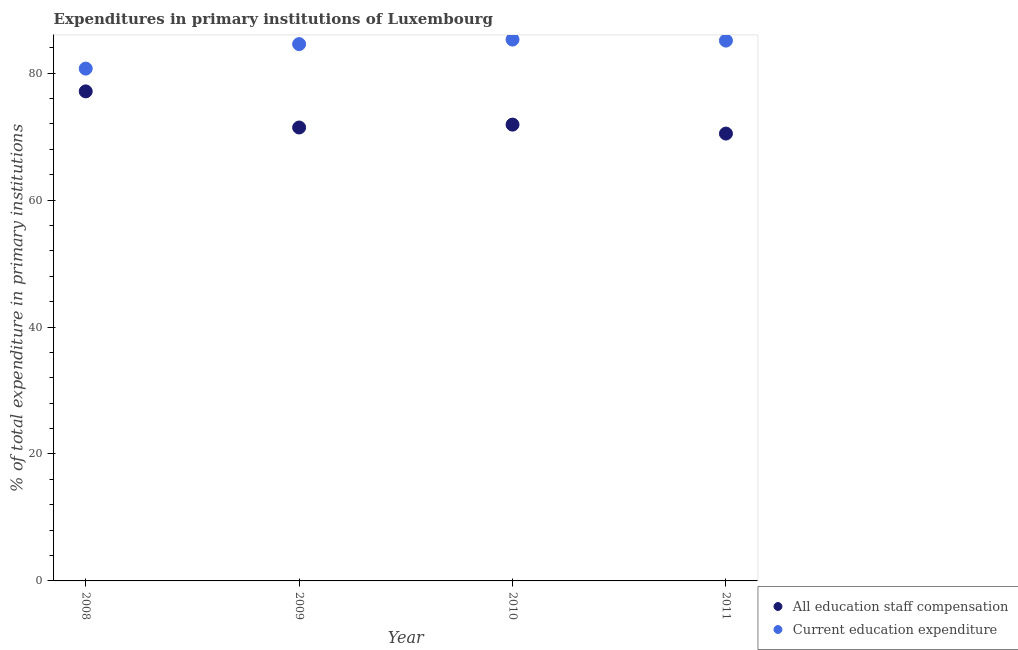What is the expenditure in staff compensation in 2010?
Give a very brief answer. 71.89. Across all years, what is the maximum expenditure in education?
Offer a very short reply. 85.29. Across all years, what is the minimum expenditure in staff compensation?
Your answer should be very brief. 70.48. In which year was the expenditure in education maximum?
Your response must be concise. 2010. What is the total expenditure in staff compensation in the graph?
Provide a succinct answer. 290.94. What is the difference between the expenditure in staff compensation in 2009 and that in 2011?
Keep it short and to the point. 0.96. What is the difference between the expenditure in staff compensation in 2011 and the expenditure in education in 2010?
Offer a terse response. -14.81. What is the average expenditure in staff compensation per year?
Offer a very short reply. 72.73. In the year 2008, what is the difference between the expenditure in staff compensation and expenditure in education?
Keep it short and to the point. -3.59. What is the ratio of the expenditure in staff compensation in 2008 to that in 2011?
Give a very brief answer. 1.09. Is the expenditure in education in 2009 less than that in 2010?
Make the answer very short. Yes. What is the difference between the highest and the second highest expenditure in staff compensation?
Your answer should be very brief. 5.24. What is the difference between the highest and the lowest expenditure in staff compensation?
Your response must be concise. 6.65. In how many years, is the expenditure in education greater than the average expenditure in education taken over all years?
Make the answer very short. 3. Is the expenditure in education strictly greater than the expenditure in staff compensation over the years?
Give a very brief answer. Yes. How many dotlines are there?
Your answer should be compact. 2. How many years are there in the graph?
Provide a succinct answer. 4. Are the values on the major ticks of Y-axis written in scientific E-notation?
Provide a succinct answer. No. Does the graph contain grids?
Ensure brevity in your answer.  No. Where does the legend appear in the graph?
Your answer should be very brief. Bottom right. What is the title of the graph?
Your response must be concise. Expenditures in primary institutions of Luxembourg. What is the label or title of the Y-axis?
Offer a terse response. % of total expenditure in primary institutions. What is the % of total expenditure in primary institutions in All education staff compensation in 2008?
Your response must be concise. 77.13. What is the % of total expenditure in primary institutions in Current education expenditure in 2008?
Make the answer very short. 80.72. What is the % of total expenditure in primary institutions in All education staff compensation in 2009?
Your answer should be very brief. 71.44. What is the % of total expenditure in primary institutions in Current education expenditure in 2009?
Your answer should be compact. 84.57. What is the % of total expenditure in primary institutions in All education staff compensation in 2010?
Your answer should be very brief. 71.89. What is the % of total expenditure in primary institutions of Current education expenditure in 2010?
Your answer should be compact. 85.29. What is the % of total expenditure in primary institutions of All education staff compensation in 2011?
Your answer should be compact. 70.48. What is the % of total expenditure in primary institutions of Current education expenditure in 2011?
Ensure brevity in your answer.  85.13. Across all years, what is the maximum % of total expenditure in primary institutions in All education staff compensation?
Provide a short and direct response. 77.13. Across all years, what is the maximum % of total expenditure in primary institutions of Current education expenditure?
Your answer should be very brief. 85.29. Across all years, what is the minimum % of total expenditure in primary institutions in All education staff compensation?
Provide a succinct answer. 70.48. Across all years, what is the minimum % of total expenditure in primary institutions in Current education expenditure?
Give a very brief answer. 80.72. What is the total % of total expenditure in primary institutions in All education staff compensation in the graph?
Your response must be concise. 290.94. What is the total % of total expenditure in primary institutions of Current education expenditure in the graph?
Provide a succinct answer. 335.71. What is the difference between the % of total expenditure in primary institutions of All education staff compensation in 2008 and that in 2009?
Give a very brief answer. 5.69. What is the difference between the % of total expenditure in primary institutions of Current education expenditure in 2008 and that in 2009?
Offer a terse response. -3.86. What is the difference between the % of total expenditure in primary institutions in All education staff compensation in 2008 and that in 2010?
Your response must be concise. 5.24. What is the difference between the % of total expenditure in primary institutions in Current education expenditure in 2008 and that in 2010?
Offer a terse response. -4.57. What is the difference between the % of total expenditure in primary institutions in All education staff compensation in 2008 and that in 2011?
Offer a very short reply. 6.65. What is the difference between the % of total expenditure in primary institutions in Current education expenditure in 2008 and that in 2011?
Offer a very short reply. -4.41. What is the difference between the % of total expenditure in primary institutions of All education staff compensation in 2009 and that in 2010?
Provide a short and direct response. -0.45. What is the difference between the % of total expenditure in primary institutions of Current education expenditure in 2009 and that in 2010?
Make the answer very short. -0.72. What is the difference between the % of total expenditure in primary institutions in All education staff compensation in 2009 and that in 2011?
Your answer should be very brief. 0.96. What is the difference between the % of total expenditure in primary institutions of Current education expenditure in 2009 and that in 2011?
Offer a terse response. -0.55. What is the difference between the % of total expenditure in primary institutions in All education staff compensation in 2010 and that in 2011?
Your answer should be very brief. 1.41. What is the difference between the % of total expenditure in primary institutions in Current education expenditure in 2010 and that in 2011?
Your answer should be compact. 0.16. What is the difference between the % of total expenditure in primary institutions in All education staff compensation in 2008 and the % of total expenditure in primary institutions in Current education expenditure in 2009?
Offer a terse response. -7.45. What is the difference between the % of total expenditure in primary institutions in All education staff compensation in 2008 and the % of total expenditure in primary institutions in Current education expenditure in 2010?
Keep it short and to the point. -8.16. What is the difference between the % of total expenditure in primary institutions of All education staff compensation in 2008 and the % of total expenditure in primary institutions of Current education expenditure in 2011?
Give a very brief answer. -8. What is the difference between the % of total expenditure in primary institutions in All education staff compensation in 2009 and the % of total expenditure in primary institutions in Current education expenditure in 2010?
Provide a succinct answer. -13.85. What is the difference between the % of total expenditure in primary institutions in All education staff compensation in 2009 and the % of total expenditure in primary institutions in Current education expenditure in 2011?
Keep it short and to the point. -13.69. What is the difference between the % of total expenditure in primary institutions in All education staff compensation in 2010 and the % of total expenditure in primary institutions in Current education expenditure in 2011?
Your answer should be compact. -13.23. What is the average % of total expenditure in primary institutions of All education staff compensation per year?
Your answer should be compact. 72.73. What is the average % of total expenditure in primary institutions in Current education expenditure per year?
Provide a succinct answer. 83.93. In the year 2008, what is the difference between the % of total expenditure in primary institutions in All education staff compensation and % of total expenditure in primary institutions in Current education expenditure?
Make the answer very short. -3.59. In the year 2009, what is the difference between the % of total expenditure in primary institutions of All education staff compensation and % of total expenditure in primary institutions of Current education expenditure?
Provide a succinct answer. -13.14. In the year 2010, what is the difference between the % of total expenditure in primary institutions in All education staff compensation and % of total expenditure in primary institutions in Current education expenditure?
Provide a short and direct response. -13.4. In the year 2011, what is the difference between the % of total expenditure in primary institutions of All education staff compensation and % of total expenditure in primary institutions of Current education expenditure?
Offer a terse response. -14.65. What is the ratio of the % of total expenditure in primary institutions of All education staff compensation in 2008 to that in 2009?
Ensure brevity in your answer.  1.08. What is the ratio of the % of total expenditure in primary institutions of Current education expenditure in 2008 to that in 2009?
Offer a very short reply. 0.95. What is the ratio of the % of total expenditure in primary institutions in All education staff compensation in 2008 to that in 2010?
Make the answer very short. 1.07. What is the ratio of the % of total expenditure in primary institutions in Current education expenditure in 2008 to that in 2010?
Your answer should be very brief. 0.95. What is the ratio of the % of total expenditure in primary institutions of All education staff compensation in 2008 to that in 2011?
Provide a succinct answer. 1.09. What is the ratio of the % of total expenditure in primary institutions in Current education expenditure in 2008 to that in 2011?
Your response must be concise. 0.95. What is the ratio of the % of total expenditure in primary institutions in All education staff compensation in 2009 to that in 2010?
Provide a succinct answer. 0.99. What is the ratio of the % of total expenditure in primary institutions in Current education expenditure in 2009 to that in 2010?
Make the answer very short. 0.99. What is the ratio of the % of total expenditure in primary institutions of All education staff compensation in 2009 to that in 2011?
Provide a short and direct response. 1.01. What is the ratio of the % of total expenditure in primary institutions in All education staff compensation in 2010 to that in 2011?
Offer a very short reply. 1.02. What is the ratio of the % of total expenditure in primary institutions of Current education expenditure in 2010 to that in 2011?
Offer a terse response. 1. What is the difference between the highest and the second highest % of total expenditure in primary institutions of All education staff compensation?
Give a very brief answer. 5.24. What is the difference between the highest and the second highest % of total expenditure in primary institutions of Current education expenditure?
Your answer should be very brief. 0.16. What is the difference between the highest and the lowest % of total expenditure in primary institutions in All education staff compensation?
Your response must be concise. 6.65. What is the difference between the highest and the lowest % of total expenditure in primary institutions of Current education expenditure?
Provide a short and direct response. 4.57. 